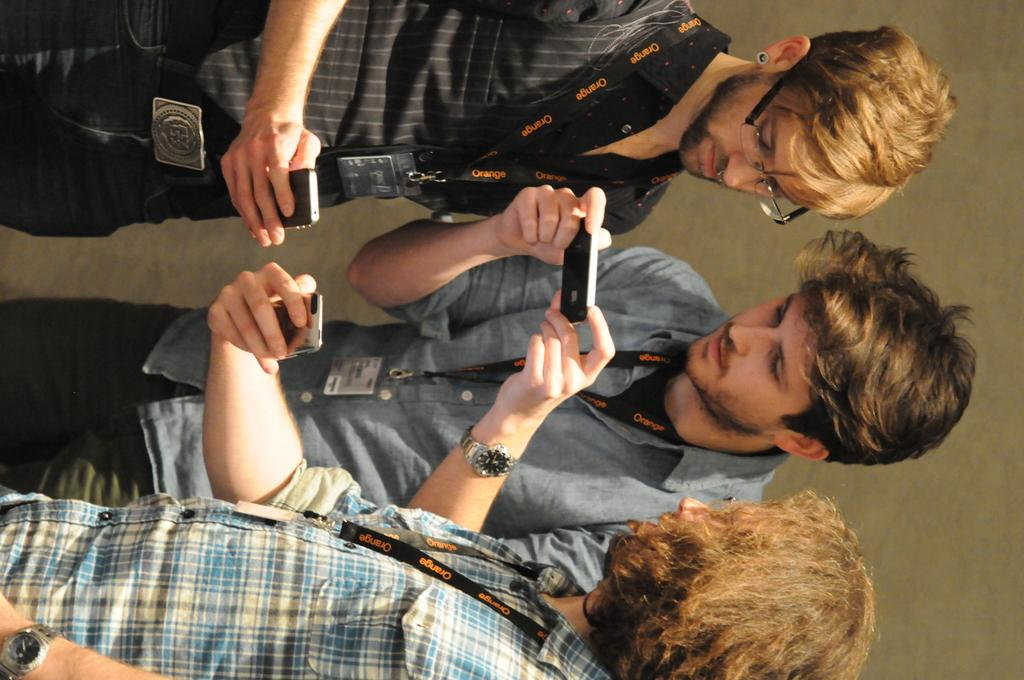What are the people in the image doing? The people in the image are standing and holding cell phones. What objects are the people holding in the image? The people are holding cell phones in the image. What can be seen in the background of the image? There is a wall in the background of the image. Can you tell me how many men are flying in the image? There are no men flying in the image; the people are standing and holding cell phones. What type of magic is being performed by the people in the image? There is no magic being performed in the image; the people are simply standing and holding cell phones. 